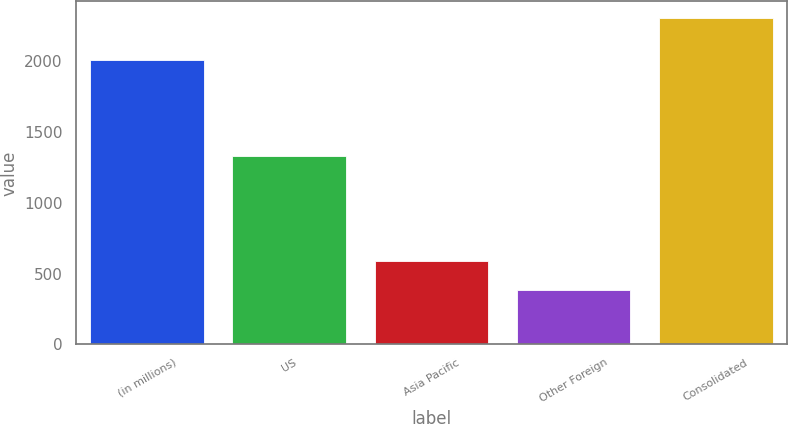<chart> <loc_0><loc_0><loc_500><loc_500><bar_chart><fcel>(in millions)<fcel>US<fcel>Asia Pacific<fcel>Other Foreign<fcel>Consolidated<nl><fcel>2011<fcel>1330<fcel>591<fcel>386<fcel>2307<nl></chart> 